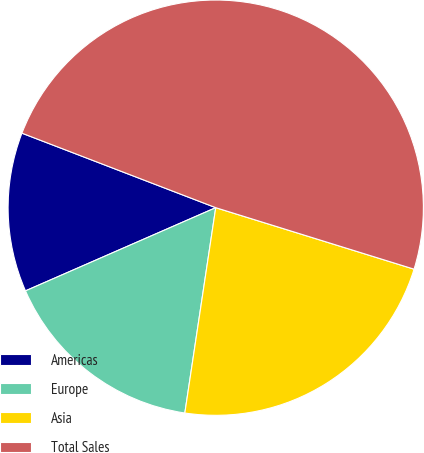Convert chart. <chart><loc_0><loc_0><loc_500><loc_500><pie_chart><fcel>Americas<fcel>Europe<fcel>Asia<fcel>Total Sales<nl><fcel>12.4%<fcel>16.06%<fcel>22.59%<fcel>48.94%<nl></chart> 